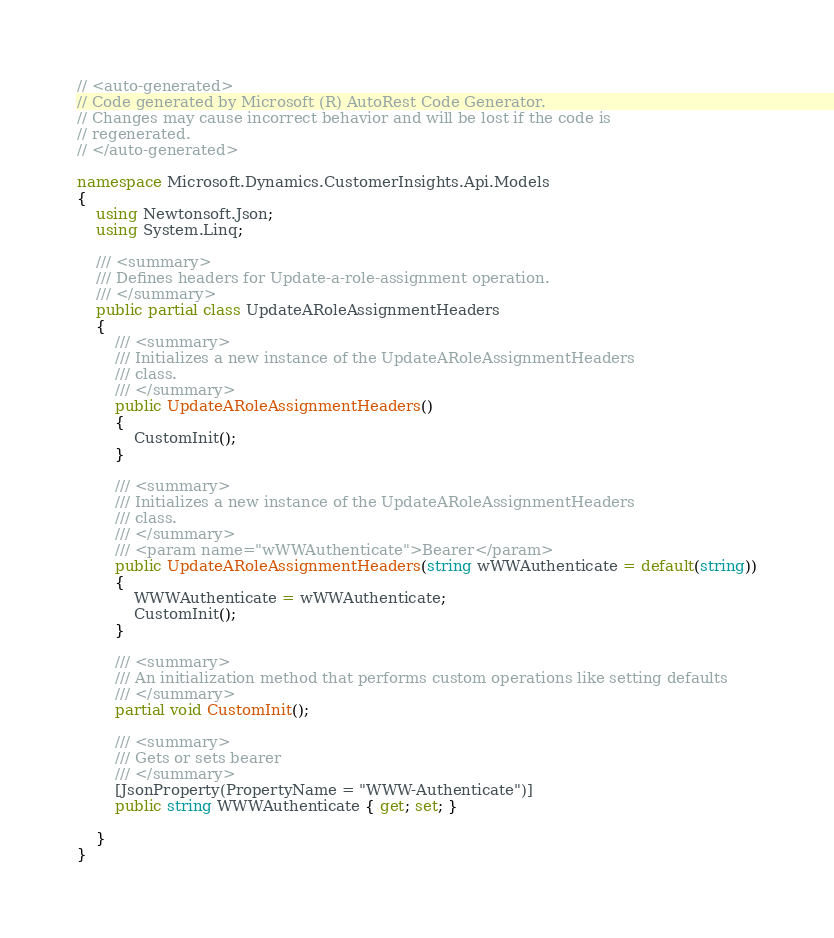<code> <loc_0><loc_0><loc_500><loc_500><_C#_>// <auto-generated>
// Code generated by Microsoft (R) AutoRest Code Generator.
// Changes may cause incorrect behavior and will be lost if the code is
// regenerated.
// </auto-generated>

namespace Microsoft.Dynamics.CustomerInsights.Api.Models
{
    using Newtonsoft.Json;
    using System.Linq;

    /// <summary>
    /// Defines headers for Update-a-role-assignment operation.
    /// </summary>
    public partial class UpdateARoleAssignmentHeaders
    {
        /// <summary>
        /// Initializes a new instance of the UpdateARoleAssignmentHeaders
        /// class.
        /// </summary>
        public UpdateARoleAssignmentHeaders()
        {
            CustomInit();
        }

        /// <summary>
        /// Initializes a new instance of the UpdateARoleAssignmentHeaders
        /// class.
        /// </summary>
        /// <param name="wWWAuthenticate">Bearer</param>
        public UpdateARoleAssignmentHeaders(string wWWAuthenticate = default(string))
        {
            WWWAuthenticate = wWWAuthenticate;
            CustomInit();
        }

        /// <summary>
        /// An initialization method that performs custom operations like setting defaults
        /// </summary>
        partial void CustomInit();

        /// <summary>
        /// Gets or sets bearer
        /// </summary>
        [JsonProperty(PropertyName = "WWW-Authenticate")]
        public string WWWAuthenticate { get; set; }

    }
}
</code> 